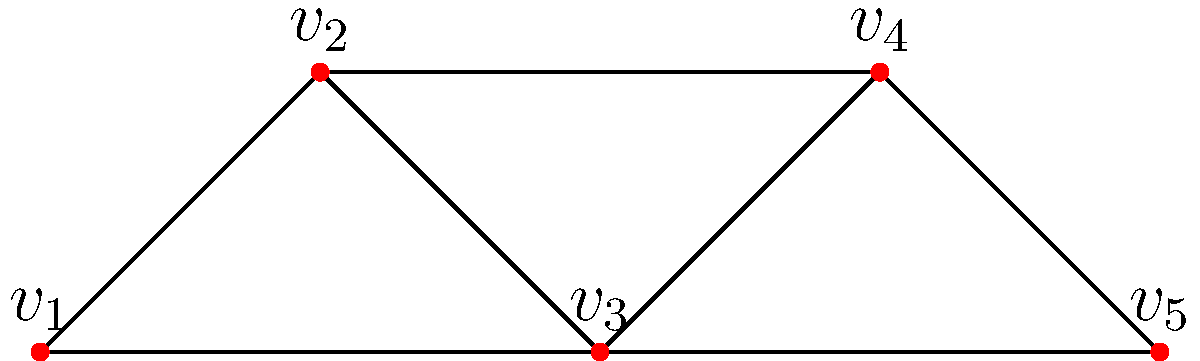Given the network graph representing global conference attendees, what is the vertex connectivity of this graph? To determine the vertex connectivity of the graph, we need to follow these steps:

1. Understand vertex connectivity: It is the minimum number of vertices that need to be removed to disconnect the graph.

2. Analyze the graph structure:
   - The graph has 5 vertices ($v_1$ to $v_5$)
   - It forms a path-like structure with some additional connections

3. Identify critical vertices:
   - Removing $v_1$ or $v_5$ doesn't disconnect the graph
   - Removing $v_2$, $v_3$, or $v_4$ individually doesn't disconnect the graph

4. Find the minimum cut set:
   - Removing $v_2$ and $v_4$ disconnects the graph into three components: $\{v_1\}$, $\{v_3\}$, and $\{v_5\}$
   - This is the smallest set of vertices that disconnects the graph

5. Count the vertices in the minimum cut set:
   - The minimum cut set contains 2 vertices

Therefore, the vertex connectivity of this graph is 2.
Answer: 2 